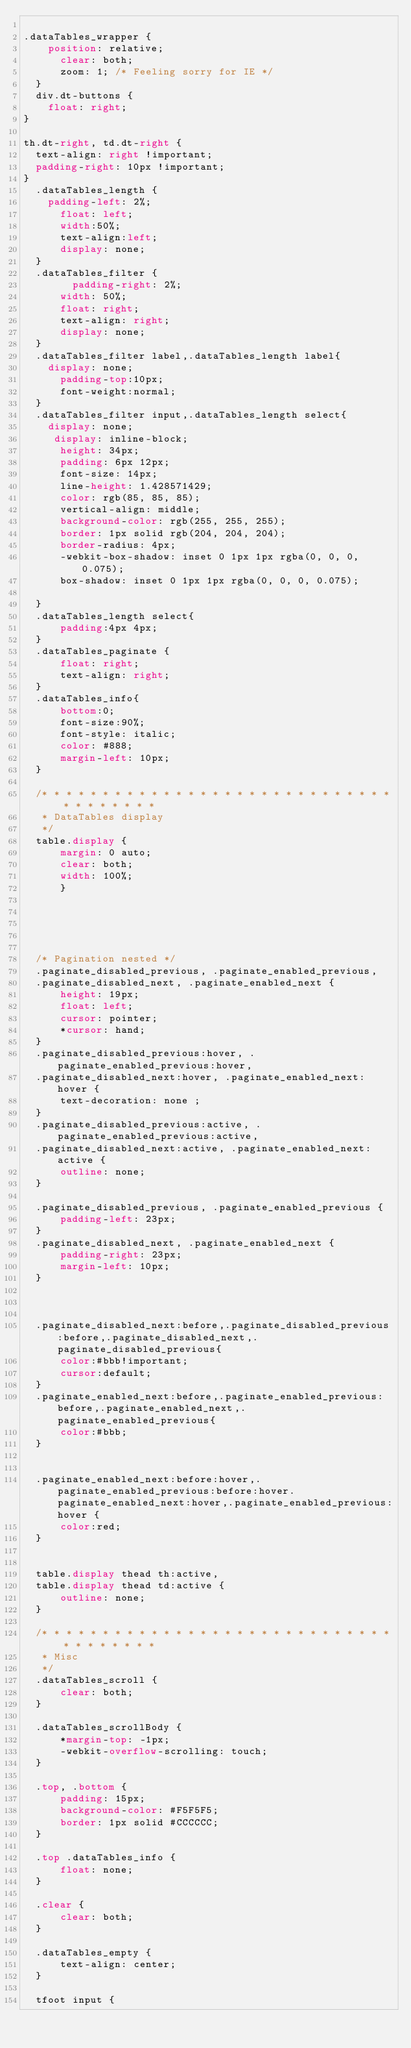Convert code to text. <code><loc_0><loc_0><loc_500><loc_500><_CSS_>
.dataTables_wrapper {
    position: relative;
      clear: both;
      zoom: 1; /* Feeling sorry for IE */
  }
  div.dt-buttons {
    float: right; 
}

th.dt-right, td.dt-right {
  text-align: right !important;
  padding-right: 10px !important; 
}
  .dataTables_length {
    padding-left: 2%;
      float: left;
      width:50%;
      text-align:left;
      display: none;
  }
  .dataTables_filter {
        padding-right: 2%;
      width: 50%;
      float: right;
      text-align: right;
      display: none;
  }
  .dataTables_filter label,.dataTables_length label{
    display: none;
      padding-top:10px;
      font-weight:normal;
  }
  .dataTables_filter input,.dataTables_length select{
    display: none;
     display: inline-block;
      height: 34px;
      padding: 6px 12px;
      font-size: 14px;
      line-height: 1.428571429;
      color: rgb(85, 85, 85);
      vertical-align: middle;
      background-color: rgb(255, 255, 255);
      border: 1px solid rgb(204, 204, 204);
      border-radius: 4px;
      -webkit-box-shadow: inset 0 1px 1px rgba(0, 0, 0, 0.075);
      box-shadow: inset 0 1px 1px rgba(0, 0, 0, 0.075);
     
  }
  .dataTables_length select{
      padding:4px 4px;
  }
  .dataTables_paginate {
      float: right;
      text-align: right;
  }
  .dataTables_info{
      bottom:0;
      font-size:90%;
      font-style: italic;
      color: #888;
      margin-left: 10px;
  }
  
  /* * * * * * * * * * * * * * * * * * * * * * * * * * * * * * * * * * * * *
   * DataTables display
   */
  table.display {
      margin: 0 auto;
      clear: both;
      width: 100%;
      }
  
  
  

 
  /* Pagination nested */
  .paginate_disabled_previous, .paginate_enabled_previous,
  .paginate_disabled_next, .paginate_enabled_next {
      height: 19px;
      float: left;
      cursor: pointer;
      *cursor: hand;
  }
  .paginate_disabled_previous:hover, .paginate_enabled_previous:hover,
  .paginate_disabled_next:hover, .paginate_enabled_next:hover {
      text-decoration: none ;
  }
  .paginate_disabled_previous:active, .paginate_enabled_previous:active,
  .paginate_disabled_next:active, .paginate_enabled_next:active {
      outline: none;
  }
  
  .paginate_disabled_previous, .paginate_enabled_previous {
      padding-left: 23px;
  }
  .paginate_disabled_next, .paginate_enabled_next {
      padding-right: 23px;
      margin-left: 10px;
  }
  
  
  
  .paginate_disabled_next:before,.paginate_disabled_previous:before,.paginate_disabled_next,.paginate_disabled_previous{
      color:#bbb!important;
      cursor:default;
  }
  .paginate_enabled_next:before,.paginate_enabled_previous:before,.paginate_enabled_next,.paginate_enabled_previous{
      color:#bbb;
  }

  
  .paginate_enabled_next:before:hover,.paginate_enabled_previous:before:hover.paginate_enabled_next:hover,.paginate_enabled_previous:hover {
      color:red;
  }
  
   
  table.display thead th:active,
  table.display thead td:active {
      outline: none;
  }
  
  /* * * * * * * * * * * * * * * * * * * * * * * * * * * * * * * * * * * * *
   * Misc
   */
  .dataTables_scroll {
      clear: both;
  }
  
  .dataTables_scrollBody {
      *margin-top: -1px;
      -webkit-overflow-scrolling: touch;
  }
  
  .top, .bottom {
      padding: 15px;
      background-color: #F5F5F5;
      border: 1px solid #CCCCCC;
  }
  
  .top .dataTables_info {
      float: none;
  }
  
  .clear {
      clear: both;
  }
  
  .dataTables_empty {
      text-align: center;
  }
  
  tfoot input {</code> 